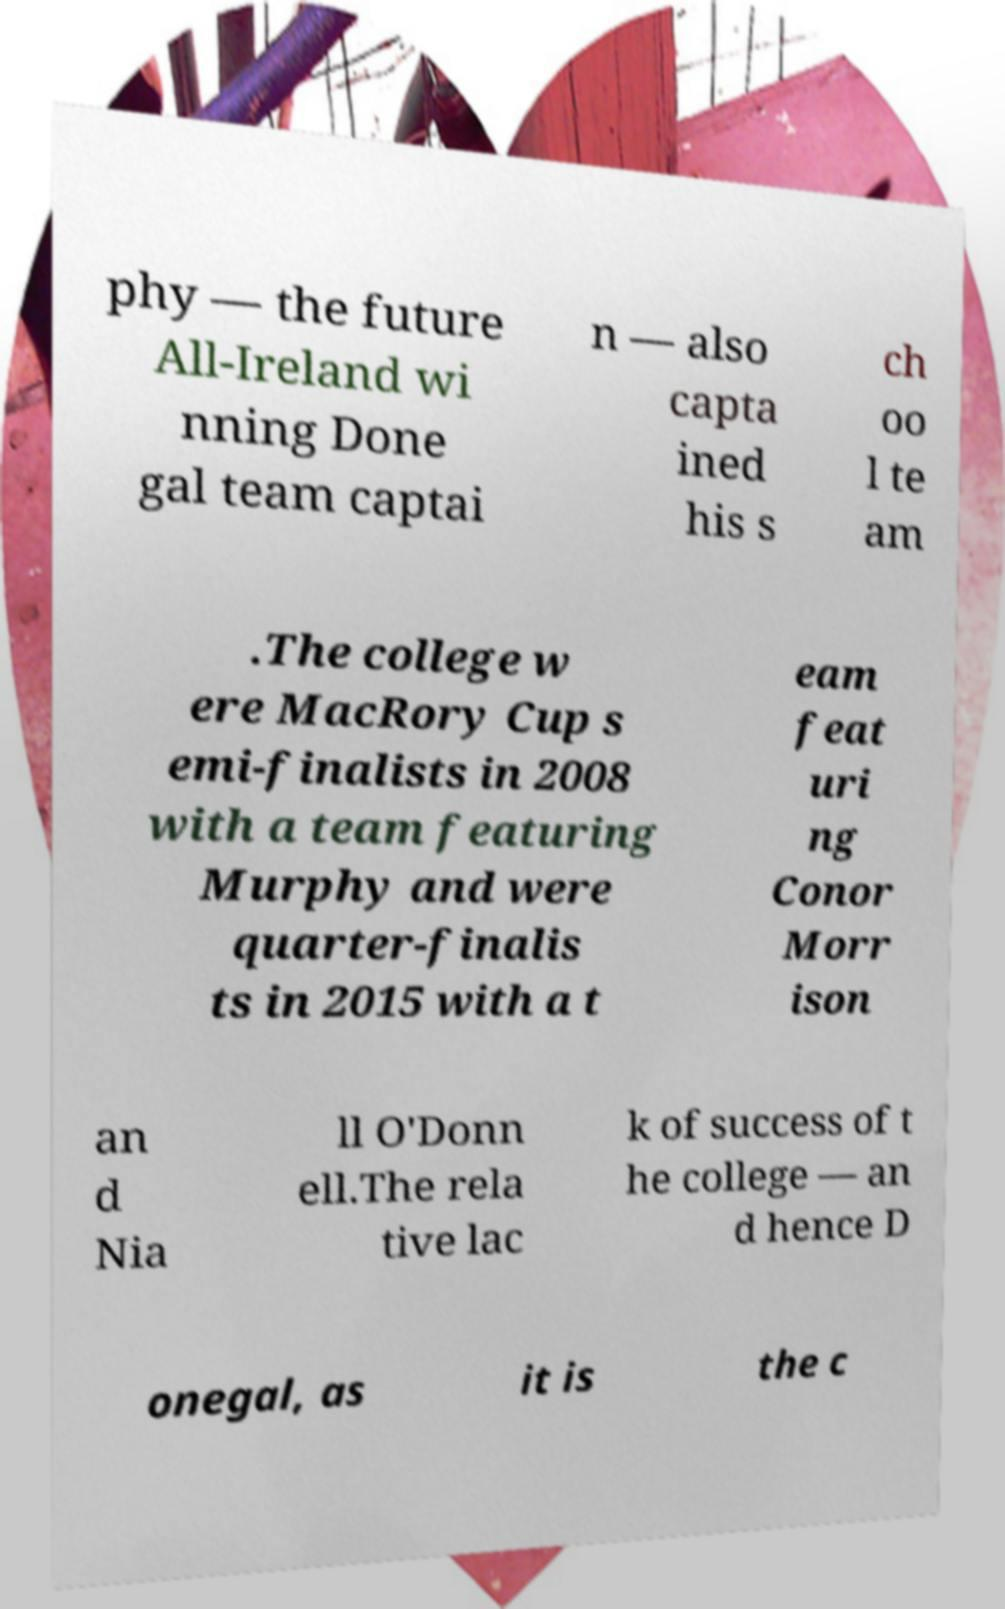I need the written content from this picture converted into text. Can you do that? phy — the future All-Ireland wi nning Done gal team captai n — also capta ined his s ch oo l te am .The college w ere MacRory Cup s emi-finalists in 2008 with a team featuring Murphy and were quarter-finalis ts in 2015 with a t eam feat uri ng Conor Morr ison an d Nia ll O'Donn ell.The rela tive lac k of success of t he college — an d hence D onegal, as it is the c 